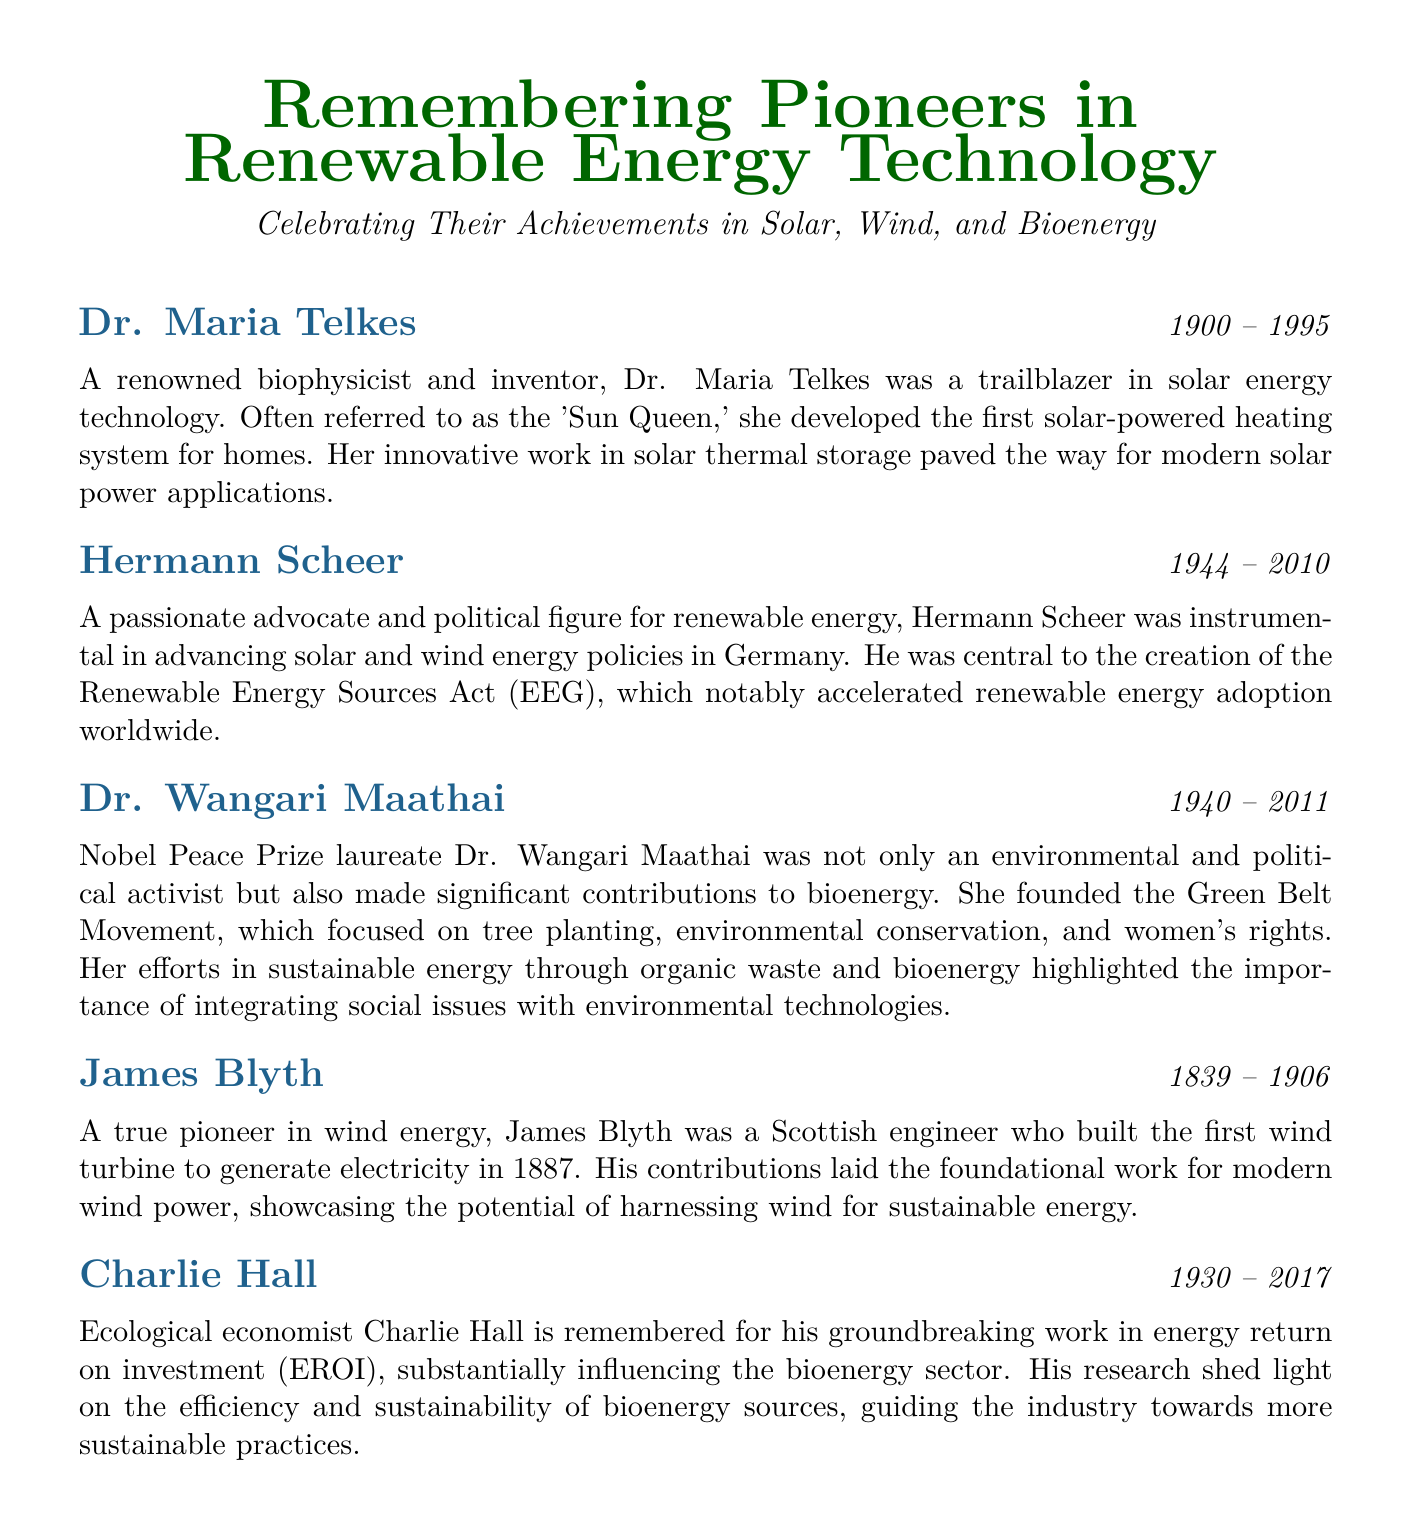What year was Dr. Maria Telkes born? The document states that Dr. Maria Telkes was born in the year 1900.
Answer: 1900 Who is referred to as the 'Sun Queen'? The document mentions that Dr. Maria Telkes is often referred to as the 'Sun Queen'.
Answer: Dr. Maria Telkes What significant act did Hermann Scheer help create? The document indicates that Hermann Scheer was central to the creation of the Renewable Energy Sources Act (EEG).
Answer: Renewable Energy Sources Act (EEG) What achievement is James Blyth known for? According to the document, James Blyth is known for building the first wind turbine to generate electricity in 1887.
Answer: First wind turbine to generate electricity In which year did Dr. Wangari Maathai pass away? The document states that Dr. Wangari Maathai passed away in 2011.
Answer: 2011 What was Charlie Hall's area of focus in energy? The document notes that Charlie Hall's focus was on energy return on investment (EROI).
Answer: Energy return on investment (EROI) Which movement did Dr. Wangari Maathai found? The document indicates that Dr. Wangari Maathai founded the Green Belt Movement.
Answer: Green Belt Movement How did Hermann Scheer contribute to renewable energy adoption? The document states that Hermann Scheer was instrumental in advancing solar and wind energy policies, which accelerated adoption worldwide.
Answer: Advancing solar and wind energy policies What type of technologies does this document celebrate? The document celebrates achievements in solar, wind, and bioenergy technologies.
Answer: Solar, wind, and bioenergy 